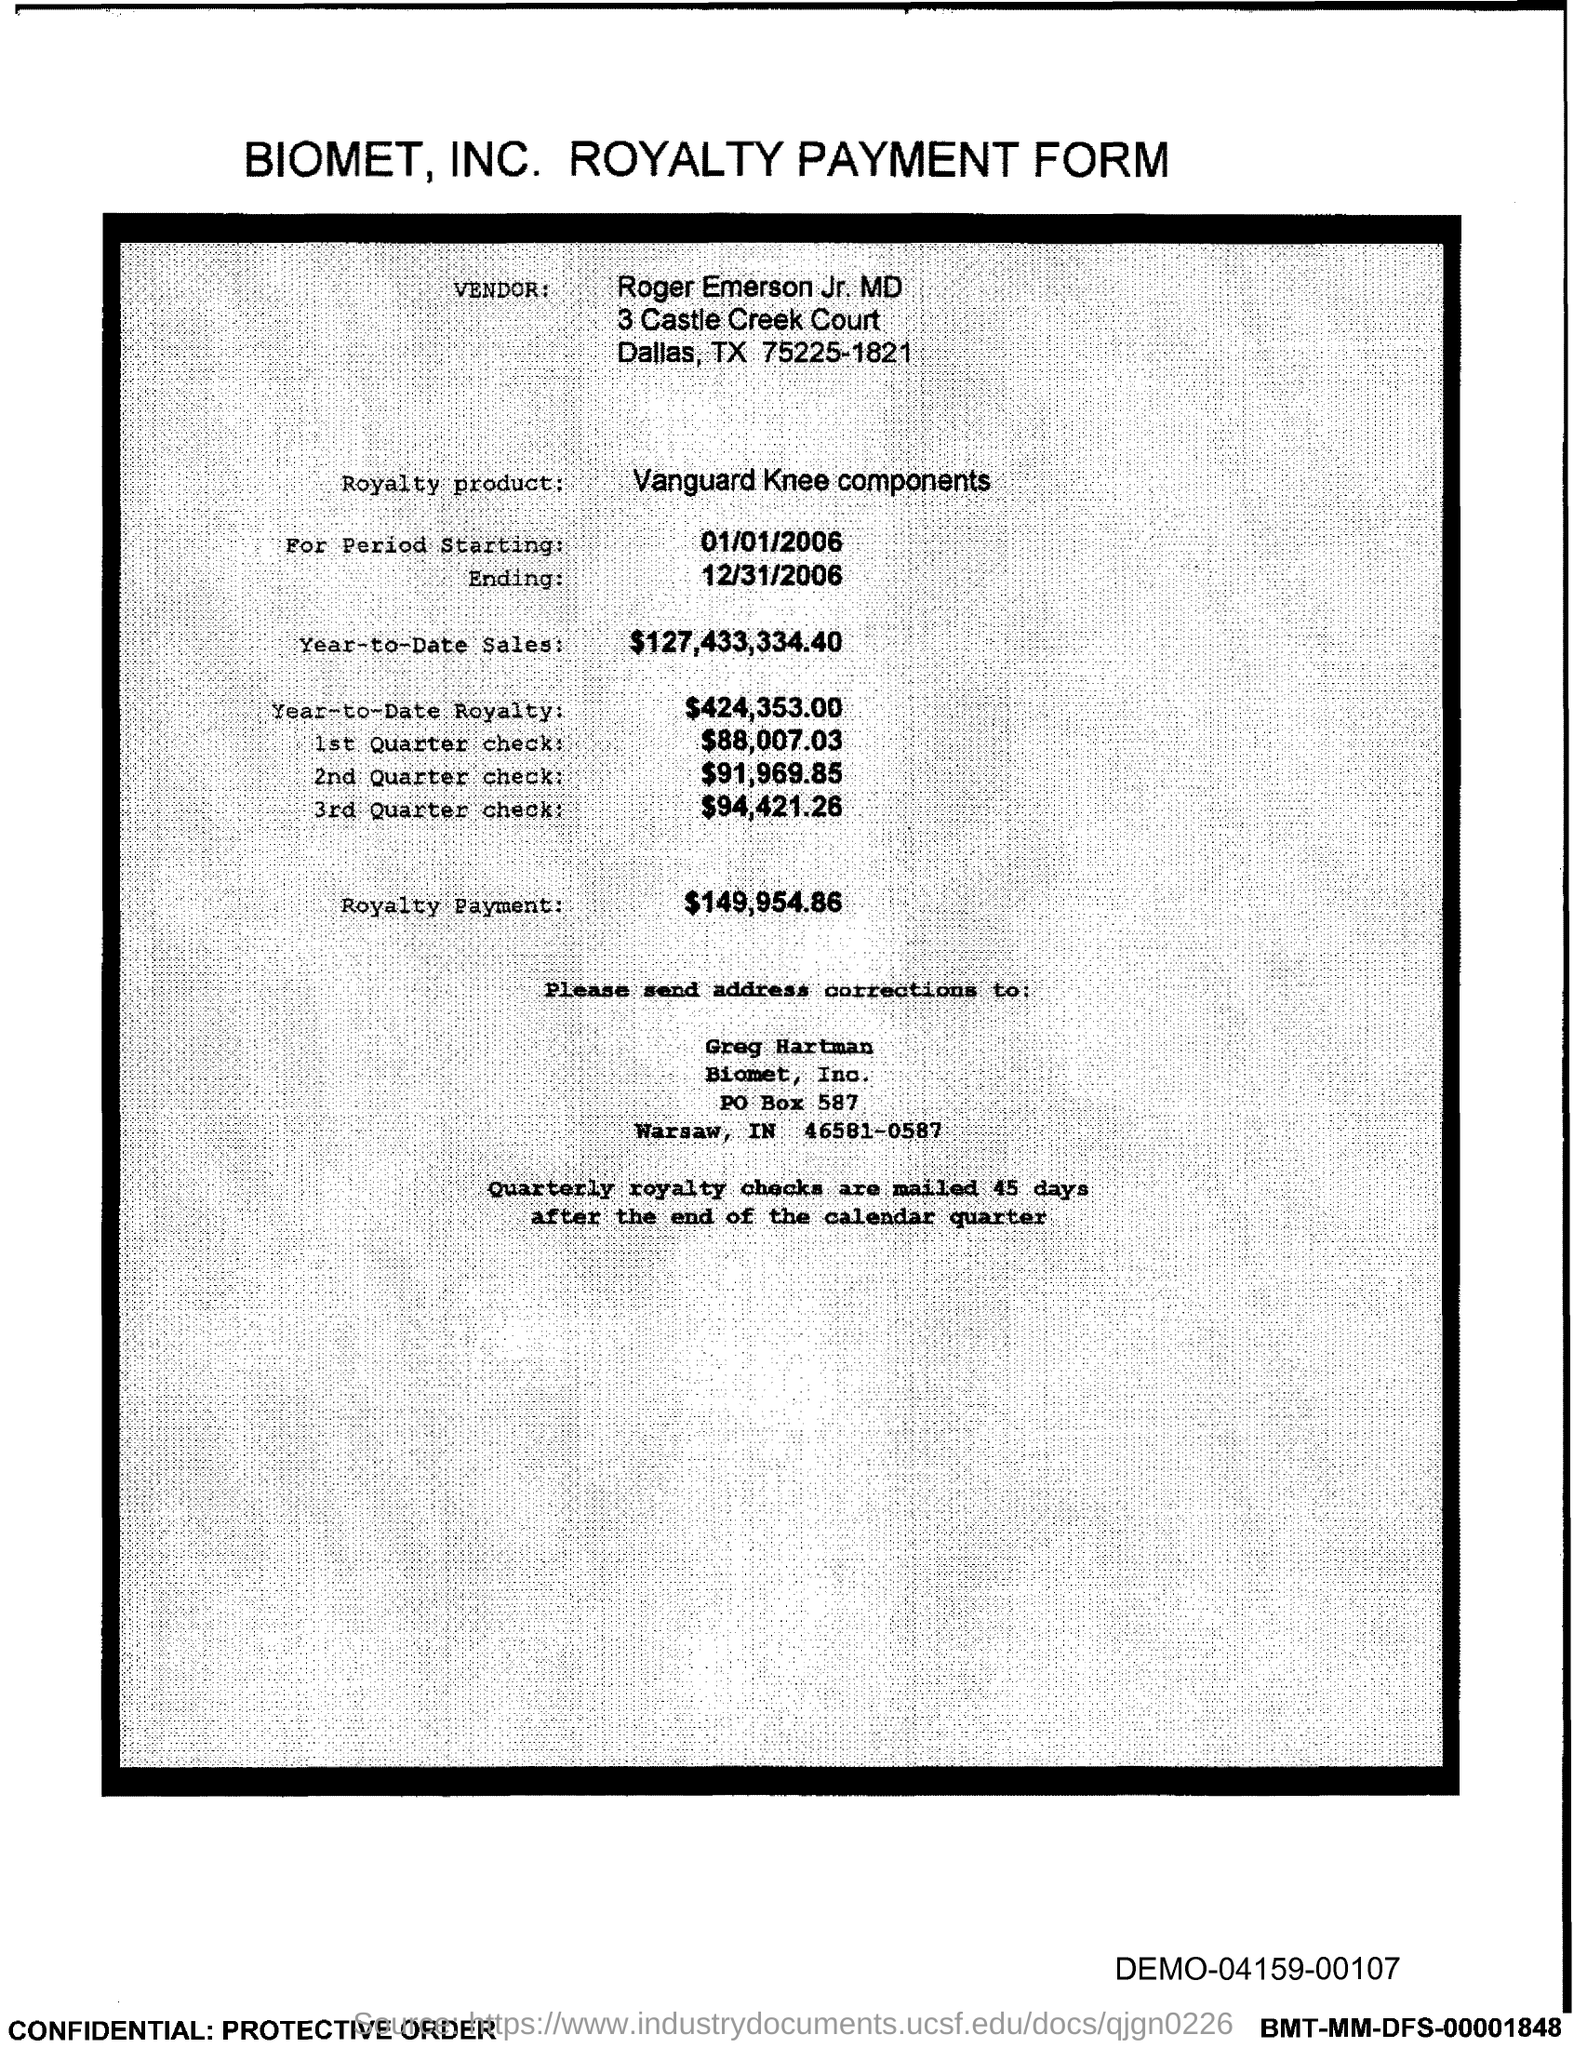Who is the vendor?
Offer a very short reply. Roger Emerson Jr. MD. What is the Royalty product mentioned?
Give a very brief answer. Vanguard Knee components. What is the royalty payment?
Provide a short and direct response. $149,954.86. To whom should address corrections be sent?
Make the answer very short. Greg Hartman. What is the amount of 1st Quarter check?
Offer a terse response. $88,007.03. 